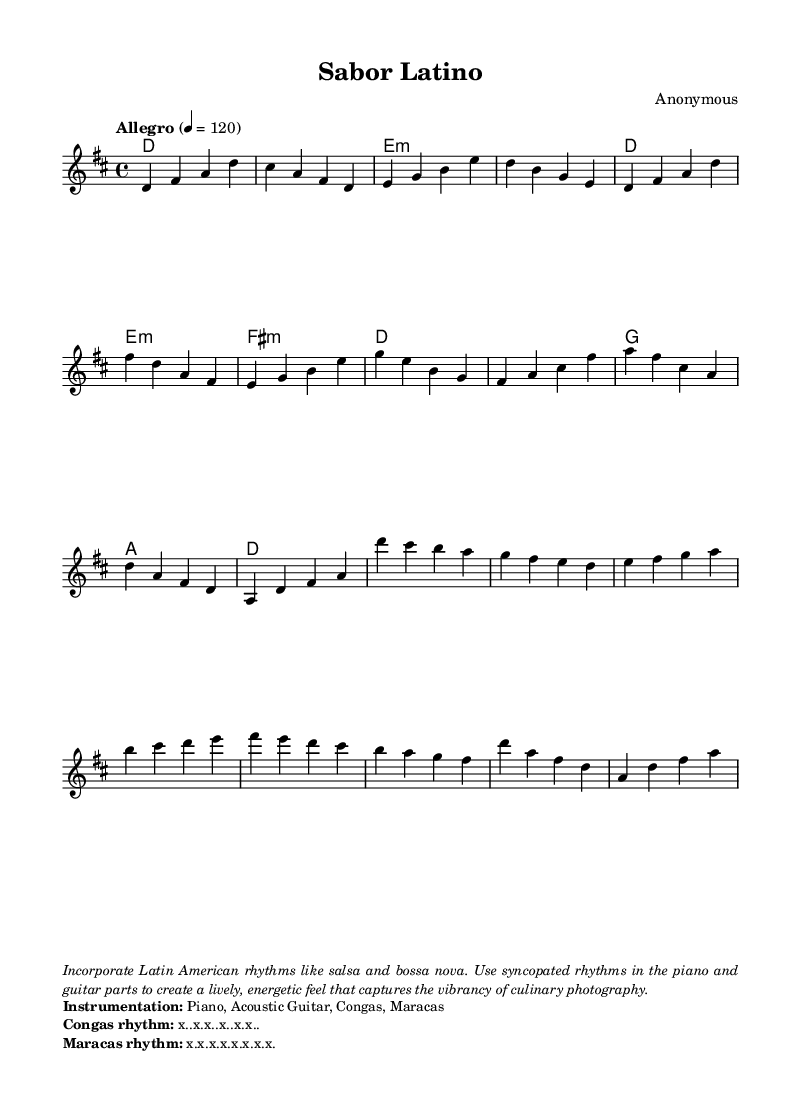What is the key signature of this music? The key signature is D major, which has two sharps (F# and C#).
Answer: D major What is the time signature of this music? The time signature is 4/4, indicating four beats per measure.
Answer: 4/4 What is the tempo marking indicated in the score? The tempo marking is "Allegro," which indicates a lively and fast tempo.
Answer: Allegro How many bars are in the intro section? The intro section consists of four bars, as represented in the notation before the verse.
Answer: 4 bars What instruments are indicated for the arrangement? The instruments listed include Piano, Acoustic Guitar, Congas, and Maracas, which add a rich texture to the piece.
Answer: Piano, Acoustic Guitar, Congas, Maracas What rhythmic pattern is suggested for the congas? The congas rhythm is represented as "x..x.x..x..x.x.." indicating a syncopated pattern that contributes to the overall groove.
Answer: x..x.x..x..x.x. Which Latin American rhythms are suggested for incorporation? The suggested rhythms for incorporation are salsa and bossa nova, adding lively and energetic elements to the music.
Answer: salsa and bossa nova 